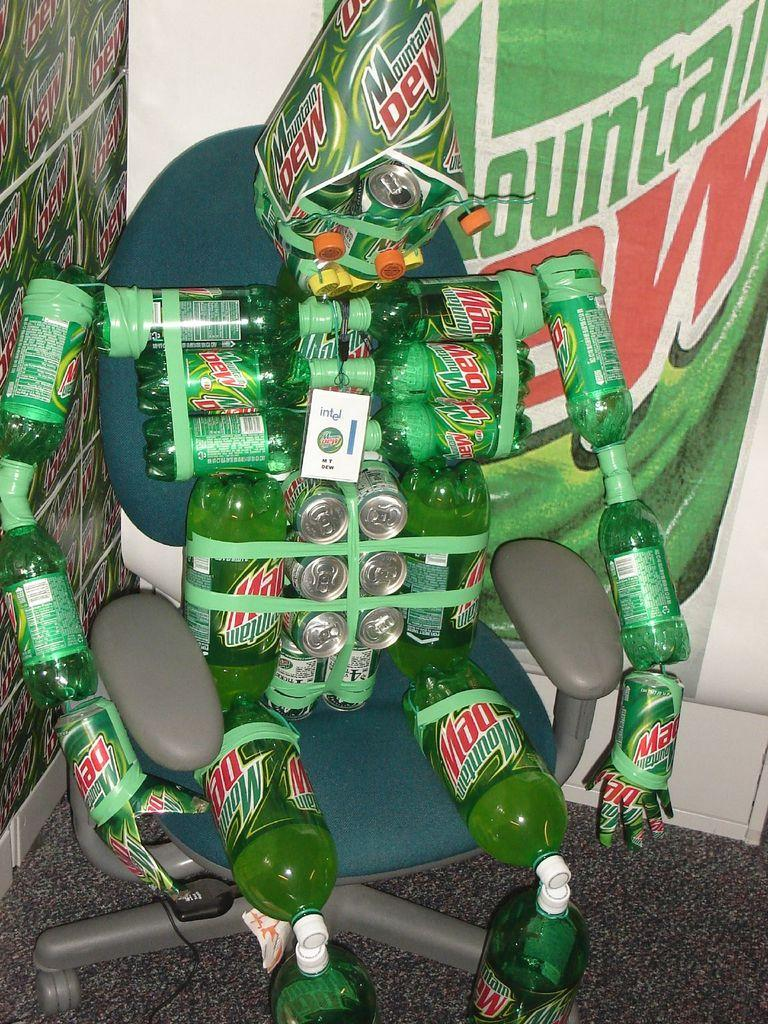<image>
Relay a brief, clear account of the picture shown. A humanoid figure constructed out out Mountain Dew bottles sits in a chair. 